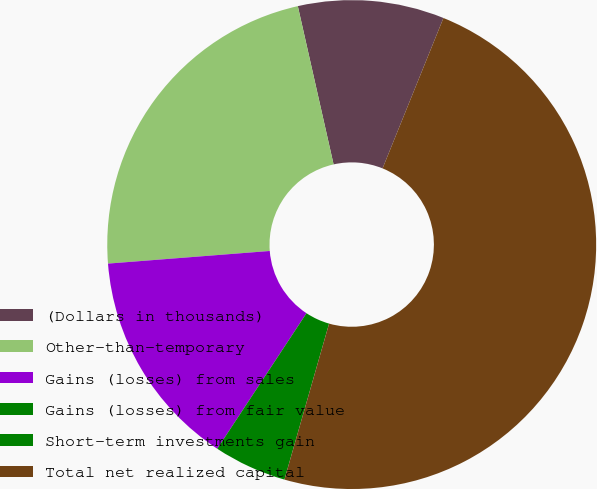Convert chart to OTSL. <chart><loc_0><loc_0><loc_500><loc_500><pie_chart><fcel>(Dollars in thousands)<fcel>Other-than-temporary<fcel>Gains (losses) from sales<fcel>Gains (losses) from fair value<fcel>Short-term investments gain<fcel>Total net realized capital<nl><fcel>9.66%<fcel>22.7%<fcel>14.49%<fcel>4.83%<fcel>0.0%<fcel>48.31%<nl></chart> 